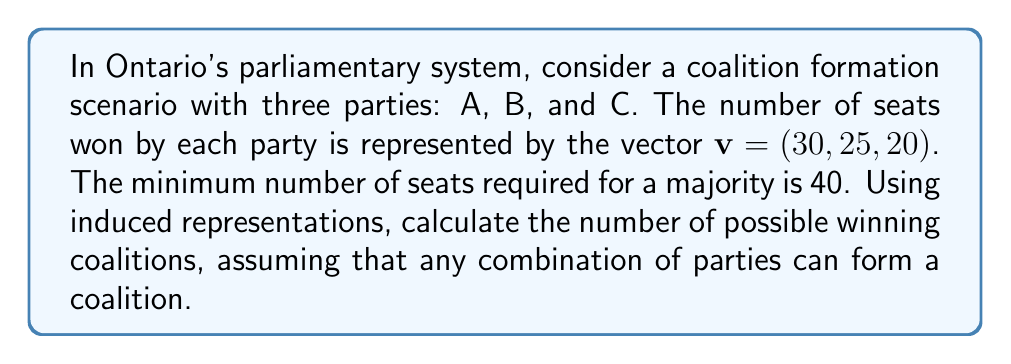Provide a solution to this math problem. To solve this problem using induced representations, we'll follow these steps:

1) First, we need to define our representation space. Let $V$ be a 3-dimensional vector space over $\mathbb{R}$ representing the possible seat distributions.

2) Define a group action of the symmetric group $S_3$ on $V$ by permuting the coordinates. This action induces a representation $\rho: S_3 \to GL(V)$.

3) Define a subspace $W \subset V$ as the set of all winning coalitions:

   $W = \{(x,y,z) \in V : x+y \geq 40 \text{ or } x+z \geq 40 \text{ or } y+z \geq 40 \text{ or } x+y+z \geq 40\}$

4) The characteristic function of $W$, $\chi_W$, is an indicator function that equals 1 for winning coalitions and 0 otherwise.

5) To count the winning coalitions, we need to evaluate $\chi_W(v)$ where $v = (30, 25, 20)$.

6) Check each possible coalition:
   - A+B: $30 + 25 = 55 \geq 40$
   - A+C: $30 + 20 = 50 \geq 40$
   - B+C: $25 + 20 = 45 \geq 40$
   - A+B+C: $30 + 25 + 20 = 75 \geq 40$

7) Each of these coalitions satisfies the winning condition, so there are 4 winning coalitions in total.

This approach uses the induced representation of $S_3$ on the space of seat distributions to systematically analyze all possible coalitions, taking into account the symmetry of the problem.
Answer: 4 